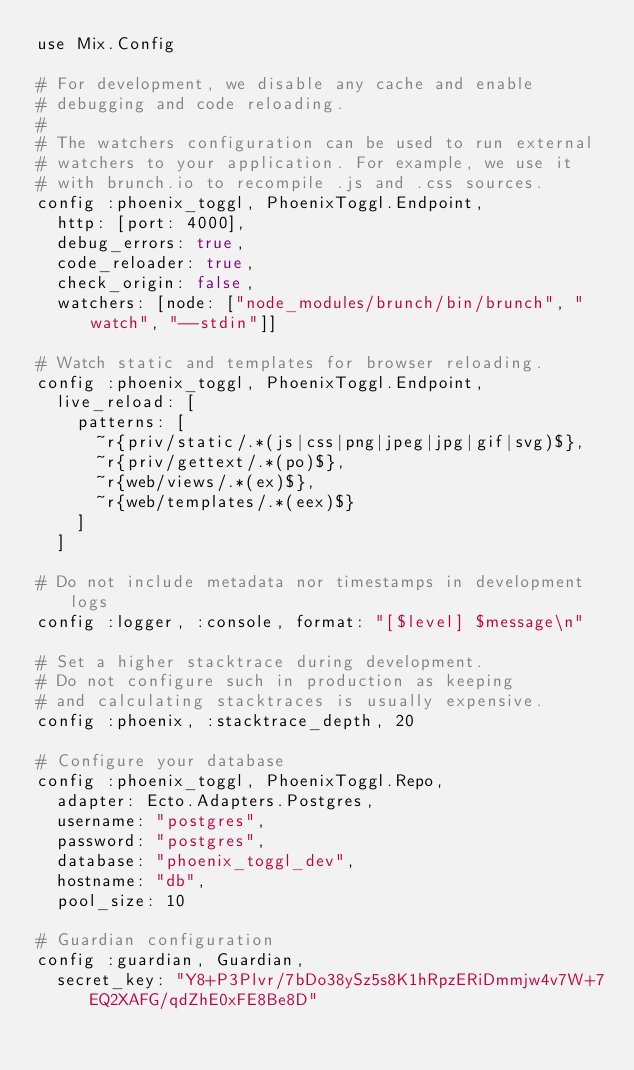<code> <loc_0><loc_0><loc_500><loc_500><_Elixir_>use Mix.Config

# For development, we disable any cache and enable
# debugging and code reloading.
#
# The watchers configuration can be used to run external
# watchers to your application. For example, we use it
# with brunch.io to recompile .js and .css sources.
config :phoenix_toggl, PhoenixToggl.Endpoint,
  http: [port: 4000],
  debug_errors: true,
  code_reloader: true,
  check_origin: false,
  watchers: [node: ["node_modules/brunch/bin/brunch", "watch", "--stdin"]]

# Watch static and templates for browser reloading.
config :phoenix_toggl, PhoenixToggl.Endpoint,
  live_reload: [
    patterns: [
      ~r{priv/static/.*(js|css|png|jpeg|jpg|gif|svg)$},
      ~r{priv/gettext/.*(po)$},
      ~r{web/views/.*(ex)$},
      ~r{web/templates/.*(eex)$}
    ]
  ]

# Do not include metadata nor timestamps in development logs
config :logger, :console, format: "[$level] $message\n"

# Set a higher stacktrace during development.
# Do not configure such in production as keeping
# and calculating stacktraces is usually expensive.
config :phoenix, :stacktrace_depth, 20

# Configure your database
config :phoenix_toggl, PhoenixToggl.Repo,
  adapter: Ecto.Adapters.Postgres,
  username: "postgres",
  password: "postgres",
  database: "phoenix_toggl_dev",
  hostname: "db",
  pool_size: 10

# Guardian configuration
config :guardian, Guardian,
  secret_key: "Y8+P3Plvr/7bDo38ySz5s8K1hRpzERiDmmjw4v7W+7EQ2XAFG/qdZhE0xFE8Be8D"
</code> 